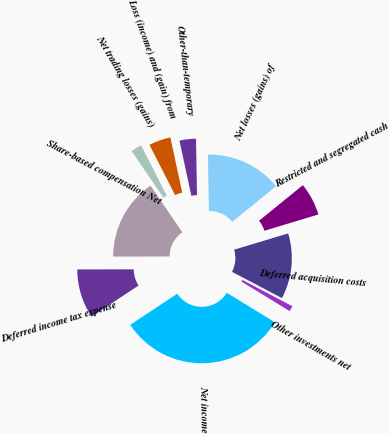Convert chart. <chart><loc_0><loc_0><loc_500><loc_500><pie_chart><fcel>Net income<fcel>Deferred income tax expense<fcel>Share-based compensation Net<fcel>Net trading losses (gains)<fcel>Loss (income) and (gain) from<fcel>Other-than-temporary<fcel>Net losses (gains) of<fcel>Restricted and segregated cash<fcel>Deferred acquisition costs<fcel>Other investments net<nl><fcel>31.95%<fcel>9.28%<fcel>15.46%<fcel>2.06%<fcel>4.12%<fcel>3.09%<fcel>14.43%<fcel>6.19%<fcel>12.37%<fcel>1.03%<nl></chart> 